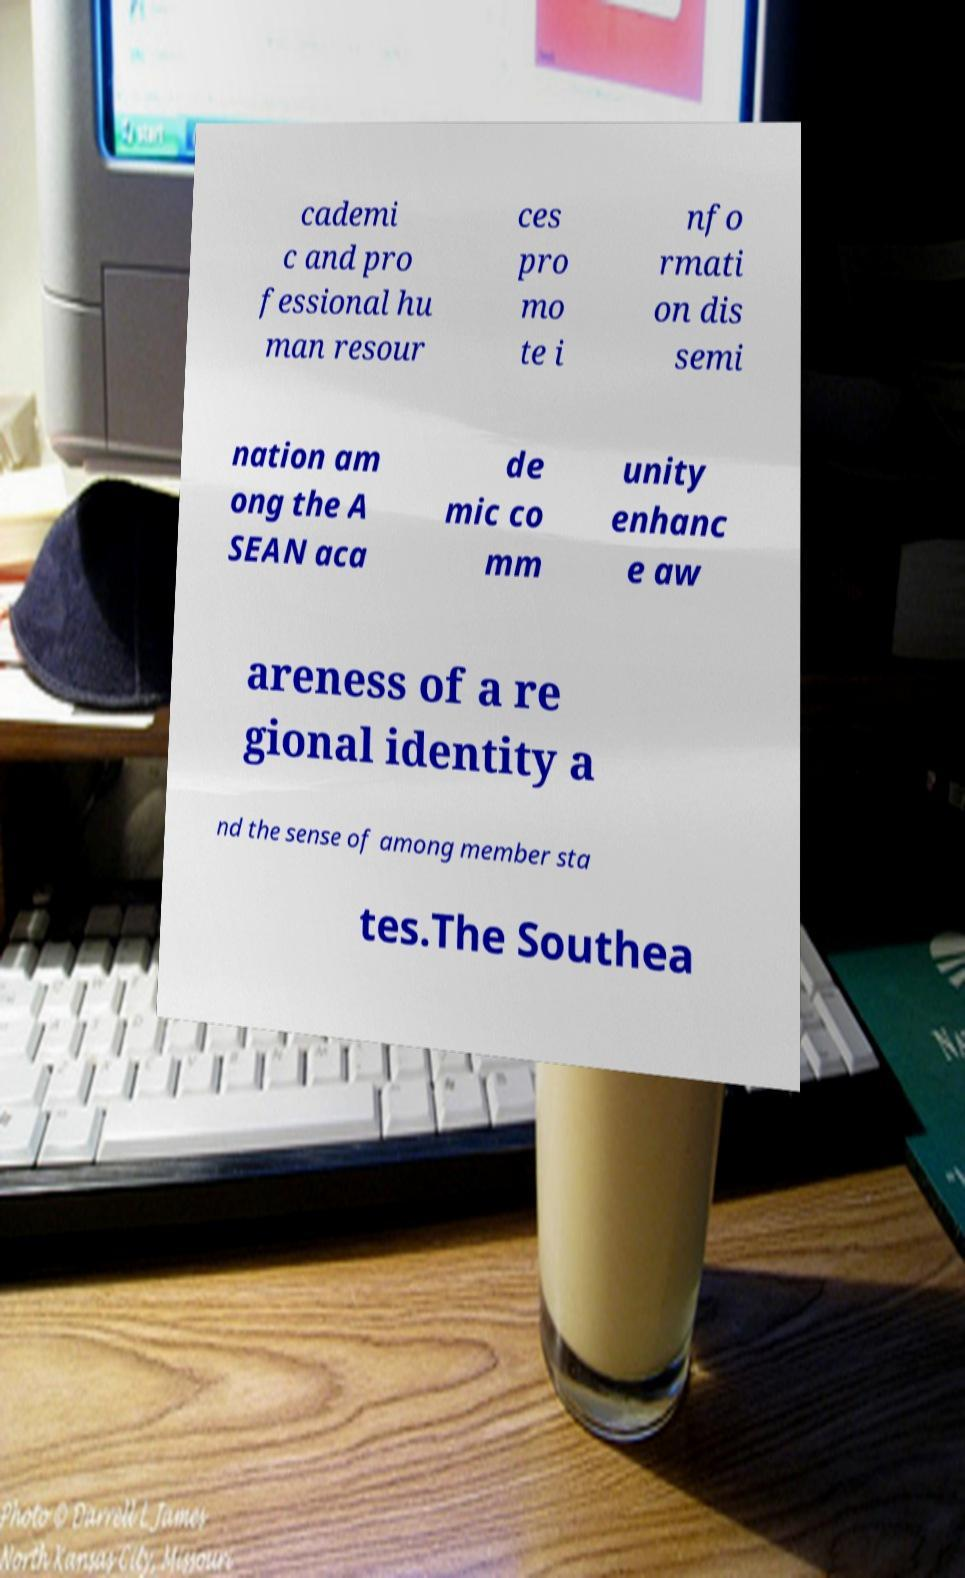Please identify and transcribe the text found in this image. cademi c and pro fessional hu man resour ces pro mo te i nfo rmati on dis semi nation am ong the A SEAN aca de mic co mm unity enhanc e aw areness of a re gional identity a nd the sense of among member sta tes.The Southea 